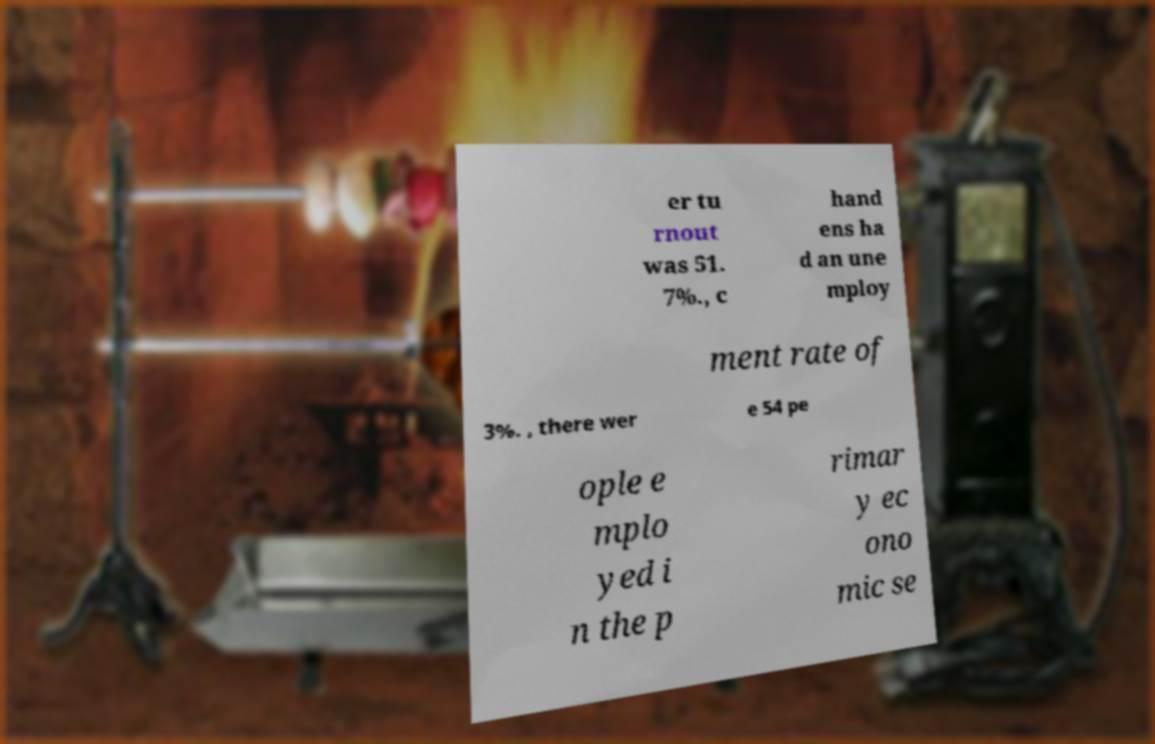Can you accurately transcribe the text from the provided image for me? er tu rnout was 51. 7%., c hand ens ha d an une mploy ment rate of 3%. , there wer e 54 pe ople e mplo yed i n the p rimar y ec ono mic se 